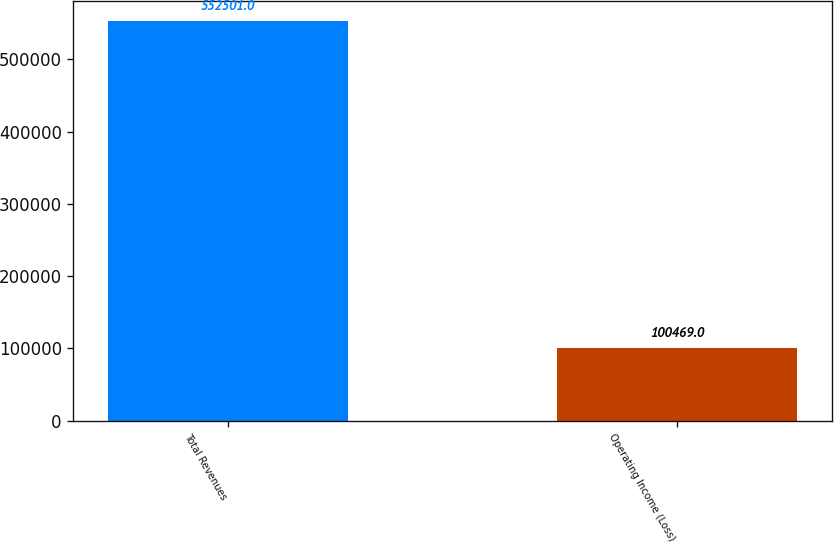Convert chart. <chart><loc_0><loc_0><loc_500><loc_500><bar_chart><fcel>Total Revenues<fcel>Operating Income (Loss)<nl><fcel>552501<fcel>100469<nl></chart> 